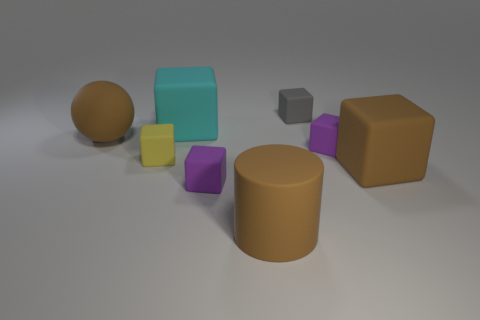Do the large brown cylinder and the cyan block have the same material?
Keep it short and to the point. Yes. There is a yellow matte block behind the big brown matte thing that is right of the tiny gray object; how many large spheres are in front of it?
Ensure brevity in your answer.  0. What is the color of the large block behind the large ball?
Keep it short and to the point. Cyan. What shape is the large thing in front of the big matte block that is to the right of the cyan object?
Offer a very short reply. Cylinder. Is the color of the large ball the same as the big cylinder?
Provide a succinct answer. Yes. How many balls are small objects or brown things?
Ensure brevity in your answer.  1. What is the big object that is in front of the large cyan matte thing and behind the brown rubber block made of?
Give a very brief answer. Rubber. How many tiny purple matte blocks are in front of the brown cylinder?
Ensure brevity in your answer.  0. Is the big thing behind the big ball made of the same material as the big brown object that is on the right side of the gray cube?
Ensure brevity in your answer.  Yes. What number of things are either rubber cubes on the right side of the cylinder or big cyan cubes?
Provide a succinct answer. 4. 